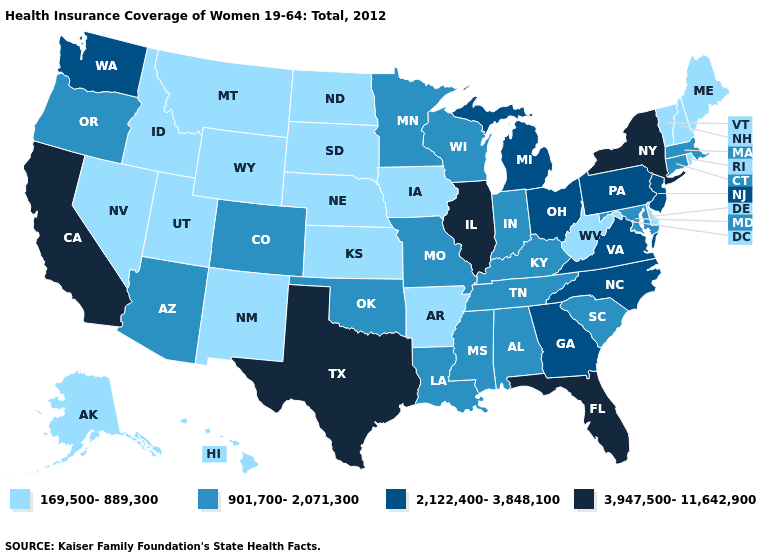Among the states that border Kentucky , does West Virginia have the lowest value?
Answer briefly. Yes. Name the states that have a value in the range 169,500-889,300?
Quick response, please. Alaska, Arkansas, Delaware, Hawaii, Idaho, Iowa, Kansas, Maine, Montana, Nebraska, Nevada, New Hampshire, New Mexico, North Dakota, Rhode Island, South Dakota, Utah, Vermont, West Virginia, Wyoming. Which states have the lowest value in the USA?
Quick response, please. Alaska, Arkansas, Delaware, Hawaii, Idaho, Iowa, Kansas, Maine, Montana, Nebraska, Nevada, New Hampshire, New Mexico, North Dakota, Rhode Island, South Dakota, Utah, Vermont, West Virginia, Wyoming. Is the legend a continuous bar?
Write a very short answer. No. Name the states that have a value in the range 3,947,500-11,642,900?
Give a very brief answer. California, Florida, Illinois, New York, Texas. Which states have the lowest value in the West?
Quick response, please. Alaska, Hawaii, Idaho, Montana, Nevada, New Mexico, Utah, Wyoming. Among the states that border Nevada , which have the highest value?
Keep it brief. California. Which states have the highest value in the USA?
Give a very brief answer. California, Florida, Illinois, New York, Texas. What is the value of Texas?
Answer briefly. 3,947,500-11,642,900. What is the value of Wyoming?
Keep it brief. 169,500-889,300. Is the legend a continuous bar?
Be succinct. No. What is the lowest value in the USA?
Concise answer only. 169,500-889,300. Name the states that have a value in the range 901,700-2,071,300?
Give a very brief answer. Alabama, Arizona, Colorado, Connecticut, Indiana, Kentucky, Louisiana, Maryland, Massachusetts, Minnesota, Mississippi, Missouri, Oklahoma, Oregon, South Carolina, Tennessee, Wisconsin. What is the value of Virginia?
Give a very brief answer. 2,122,400-3,848,100. Name the states that have a value in the range 901,700-2,071,300?
Answer briefly. Alabama, Arizona, Colorado, Connecticut, Indiana, Kentucky, Louisiana, Maryland, Massachusetts, Minnesota, Mississippi, Missouri, Oklahoma, Oregon, South Carolina, Tennessee, Wisconsin. 